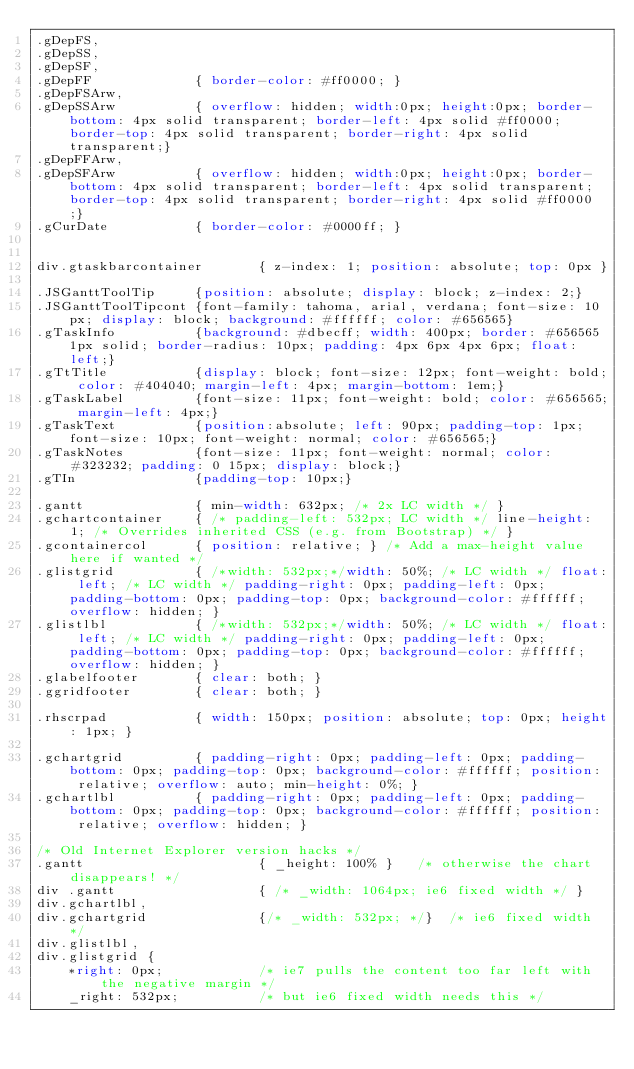<code> <loc_0><loc_0><loc_500><loc_500><_CSS_>.gDepFS,
.gDepSS,
.gDepSF,
.gDepFF				{ border-color: #ff0000; }
.gDepFSArw,
.gDepSSArw			{ overflow: hidden; width:0px; height:0px; border-bottom: 4px solid transparent; border-left: 4px solid #ff0000; border-top: 4px solid transparent; border-right: 4px solid transparent;}
.gDepFFArw,
.gDepSFArw			{ overflow: hidden; width:0px; height:0px; border-bottom: 4px solid transparent; border-left: 4px solid transparent; border-top: 4px solid transparent; border-right: 4px solid #ff0000;}
.gCurDate			{ border-color: #0000ff; }


div.gtaskbarcontainer		{ z-index: 1; position: absolute; top: 0px }

.JSGanttToolTip		{position: absolute; display: block; z-index: 2;}
.JSGanttToolTipcont	{font-family: tahoma, arial, verdana; font-size: 10px; display: block; background: #ffffff; color: #656565}
.gTaskInfo			{background: #dbecff; width: 400px; border: #656565 1px solid; border-radius: 10px; padding: 4px 6px 4px 6px; float: left;}
.gTtTitle			{display: block; font-size: 12px; font-weight: bold; color: #404040; margin-left: 4px; margin-bottom: 1em;}
.gTaskLabel 		{font-size: 11px; font-weight: bold; color: #656565; margin-left: 4px;}
.gTaskText	 		{position:absolute; left: 90px; padding-top: 1px; font-size: 10px; font-weight: normal; color: #656565;}
.gTaskNotes 		{font-size: 11px; font-weight: normal; color: #323232; padding: 0 15px; display: block;}
.gTIn	 			{padding-top: 10px;}

.gantt				{ min-width: 632px;	/* 2x LC width */ }
.gchartcontainer	{ /* padding-left: 532px; LC width */ line-height: 1; /* Overrides inherited CSS (e.g. from Bootstrap) */ }
.gcontainercol		{ position: relative; } /* Add a max-height value here if wanted */
.glistgrid			{ /*width: 532px;*/width: 50%; /* LC width */ float: left; /* LC width */ padding-right: 0px; padding-left: 0px; padding-bottom: 0px; padding-top: 0px; background-color: #ffffff; overflow: hidden; }
.glistlbl			{ /*width: 532px;*/width: 50%; /* LC width */ float: left; /* LC width */ padding-right: 0px; padding-left: 0px; padding-bottom: 0px; padding-top: 0px; background-color: #ffffff; overflow: hidden; }
.glabelfooter		{ clear: both; }
.ggridfooter		{ clear: both; }

.rhscrpad			{ width: 150px; position: absolute; top: 0px; height: 1px; }

.gchartgrid			{ padding-right: 0px; padding-left: 0px; padding-bottom: 0px; padding-top: 0px; background-color: #ffffff; position: relative; overflow: auto; min-height: 0%; }
.gchartlbl			{ padding-right: 0px; padding-left: 0px; padding-bottom: 0px; padding-top: 0px; background-color: #ffffff; position: relative; overflow: hidden; }

/* Old Internet Explorer version hacks */
.gantt						{ _height: 100% }	/* otherwise the chart disappears! */
div .gantt					{ /* _width: 1064px; ie6 fixed width */ }
div.gchartlbl,
div.gchartgrid				{/* _width: 532px; */}	/* ie6 fixed width */
div.glistlbl,
div.glistgrid {
	*right: 0px;			/* ie7 pulls the content too far left with the negative margin */
	_right: 532px;			/* but ie6 fixed width needs this */</code> 